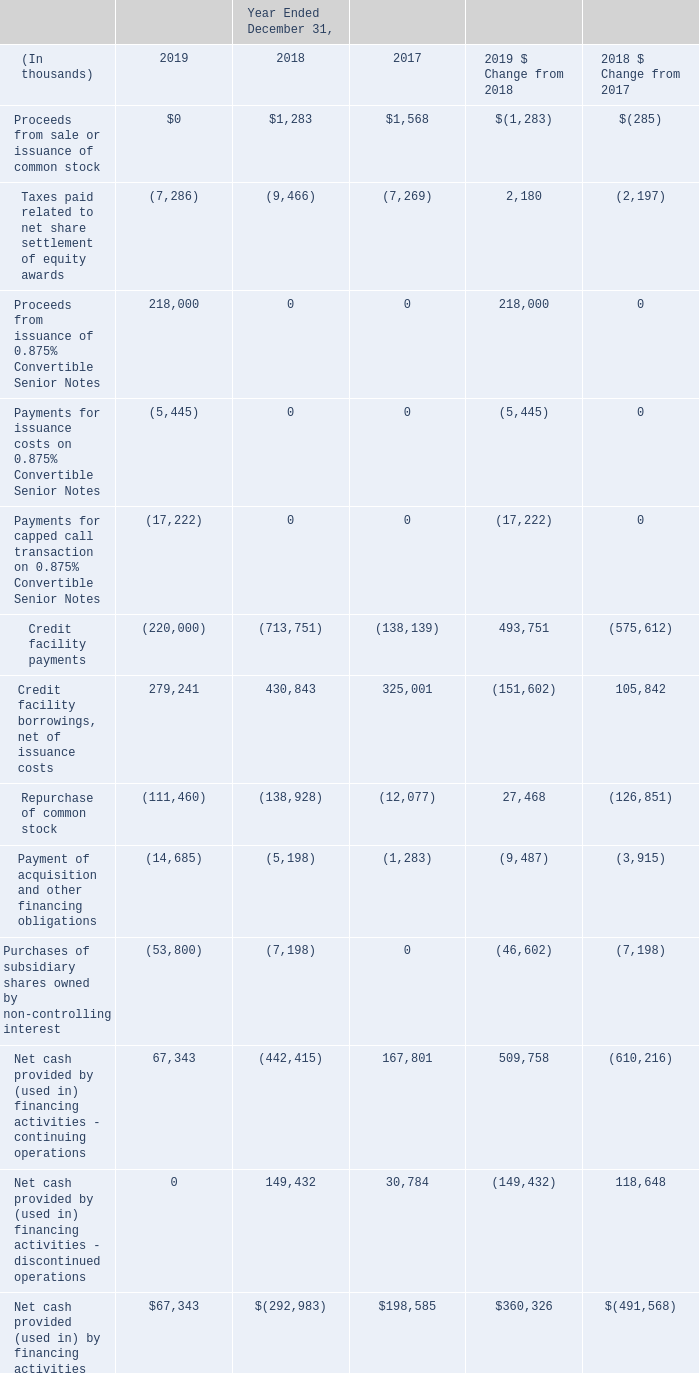Financing Cash Flow Activities
Year Ended December 31, 2019 Compared with the Year Ended December 31, 2018
Net cash provided by financing activities – continuing operations increased during the year ended December 31, 2019 primarily due to inflows resulting from (i) the issuance of the 0.875% Convertible Senior Notes, (ii) lower credit facility payments, partially offset with less credit facility borrowings and (iii) a decrease in the repurchase of common stock. These were partially offset by the purchase of the remaining minority interest in Pulse8 during 2019.
Year Ended December 31, 2018 Compared with the Year Ended December 31, 2017
We used cash in financing activities – continuing operations during the year ended December 31, 2018 compared with cash inflows from financing activities – continuing operations during the year ended December 31, 2017, which was primarily driven by higher repayments of borrowings outstanding under our senior secured credit facility and higher common stock repurchases. We used a portion of the proceeds from the sale of our investment in Netsmart to repay balances outstanding under our senior secured credit facilities at the end of 2018. We borrowed funds in 2018 to purchase Practice Fusion and Health Grid and to acquire the remaining outstanding minority interest in which we initially acquired a controlling interest in April 2015.
Net cash provided by financing activities – discontinued operations increased during the year ended December 31, 2018 compared with the prior year primarily due to higher borrowings by Netsmart used to finance business acquisitions.
What is the Proceeds from sale or issuance of common stock in 2019?
Answer scale should be: thousand. $0. What is the Proceeds from sale or issuance of common stock in 2018?
Answer scale should be: thousand. $1,283. What is the Proceeds from sale or issuance of common stock in 2017?
Answer scale should be: thousand. $1,568. What is the change in Taxes paid related to net share settlement of equity awards from 2019 to 2018?
Answer scale should be: thousand. 7,286-9,466
Answer: -2180. What is the change in Credit facility payments from 2019 to 2018?
Answer scale should be: thousand. 220,000-713,751
Answer: -493751. What is the change in Payment of acquisition and other financing obligations from 2019 to 2018?
Answer scale should be: thousand. 14,685-5,198
Answer: 9487. 